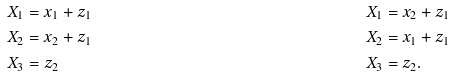<formula> <loc_0><loc_0><loc_500><loc_500>X _ { 1 } & = x _ { 1 } + z _ { 1 } & X _ { 1 } & = x _ { 2 } + z _ { 1 } \\ X _ { 2 } & = x _ { 2 } + z _ { 1 } & X _ { 2 } & = x _ { 1 } + z _ { 1 } \\ X _ { 3 } & = z _ { 2 } & X _ { 3 } & = z _ { 2 } .</formula> 